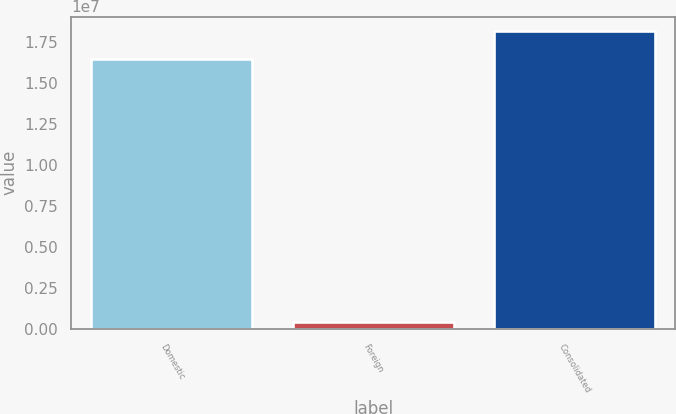Convert chart. <chart><loc_0><loc_0><loc_500><loc_500><bar_chart><fcel>Domestic<fcel>Foreign<fcel>Consolidated<nl><fcel>1.64681e+07<fcel>421870<fcel>1.81149e+07<nl></chart> 